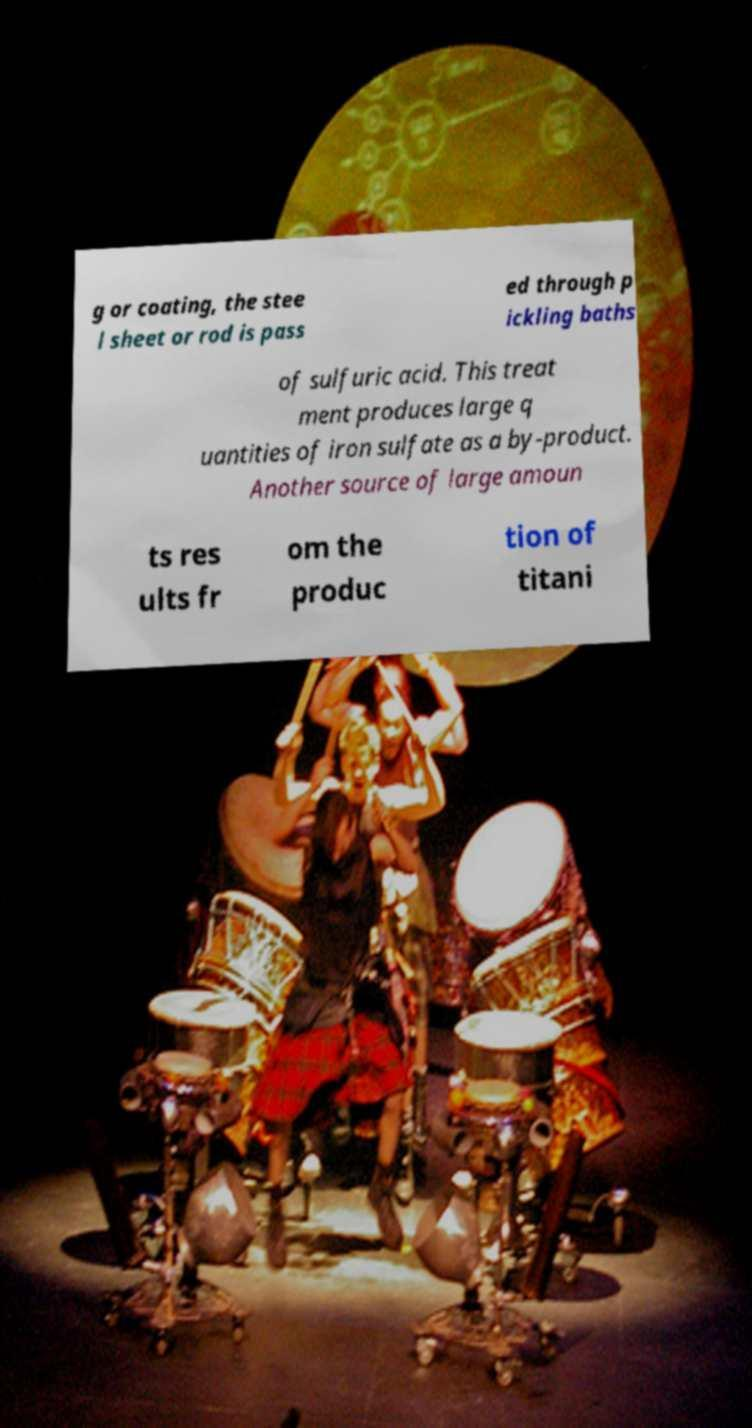I need the written content from this picture converted into text. Can you do that? g or coating, the stee l sheet or rod is pass ed through p ickling baths of sulfuric acid. This treat ment produces large q uantities of iron sulfate as a by-product. Another source of large amoun ts res ults fr om the produc tion of titani 